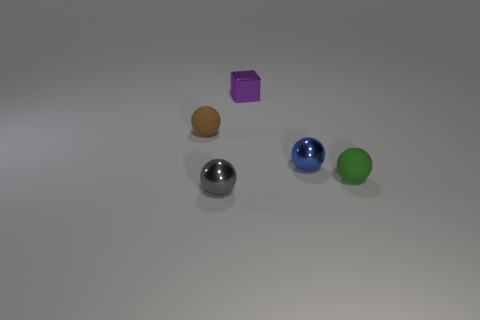Subtract all purple balls. Subtract all brown blocks. How many balls are left? 4 Add 3 yellow matte objects. How many objects exist? 8 Subtract all cubes. How many objects are left? 4 Subtract 0 cyan balls. How many objects are left? 5 Subtract all large yellow metallic things. Subtract all small metal things. How many objects are left? 2 Add 1 green things. How many green things are left? 2 Add 4 gray spheres. How many gray spheres exist? 5 